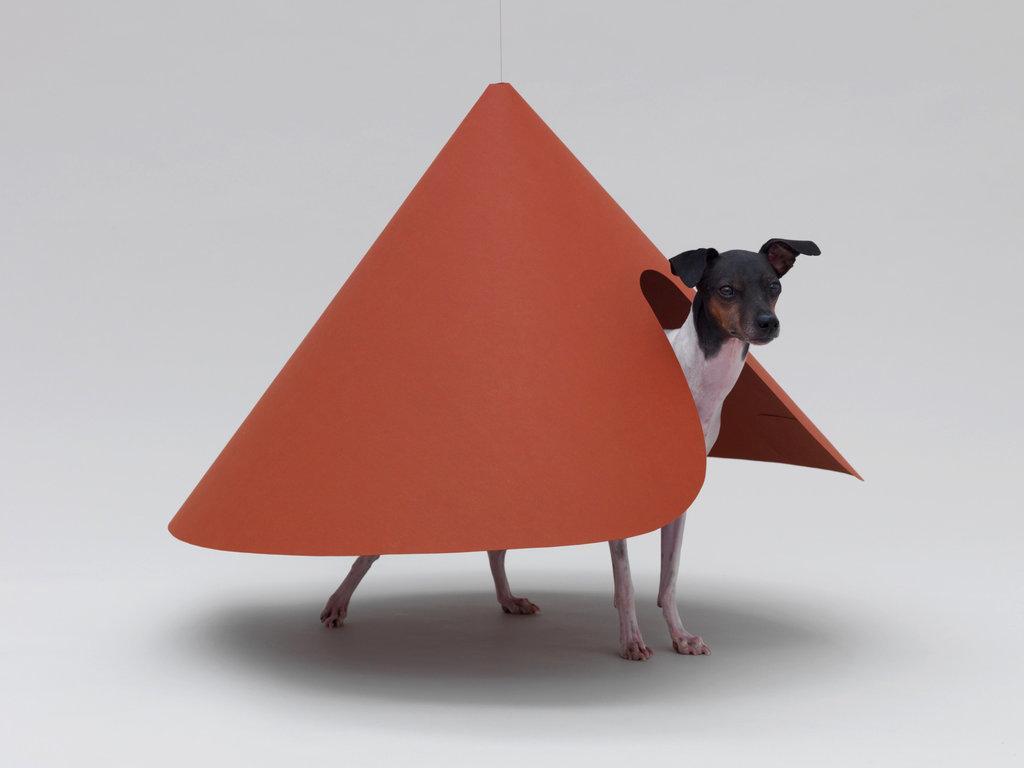Can you describe this image briefly? In this image we can see a dog and an object. In the background of the image there is a white background. 